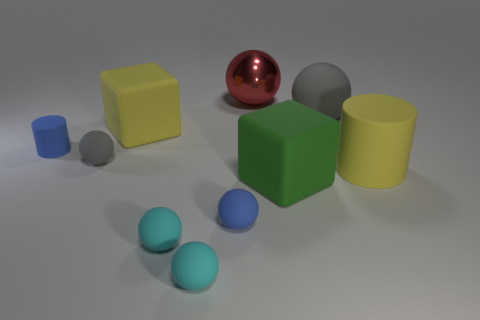Subtract all large matte spheres. How many spheres are left? 5 Subtract all brown cubes. How many gray spheres are left? 2 Subtract all red balls. How many balls are left? 5 Subtract all cubes. How many objects are left? 8 Subtract 1 spheres. How many spheres are left? 5 Subtract all blue cylinders. Subtract all blue spheres. How many cylinders are left? 1 Subtract all blue rubber balls. Subtract all large red metal balls. How many objects are left? 8 Add 9 red spheres. How many red spheres are left? 10 Add 8 tiny blue cylinders. How many tiny blue cylinders exist? 9 Subtract 0 green cylinders. How many objects are left? 10 